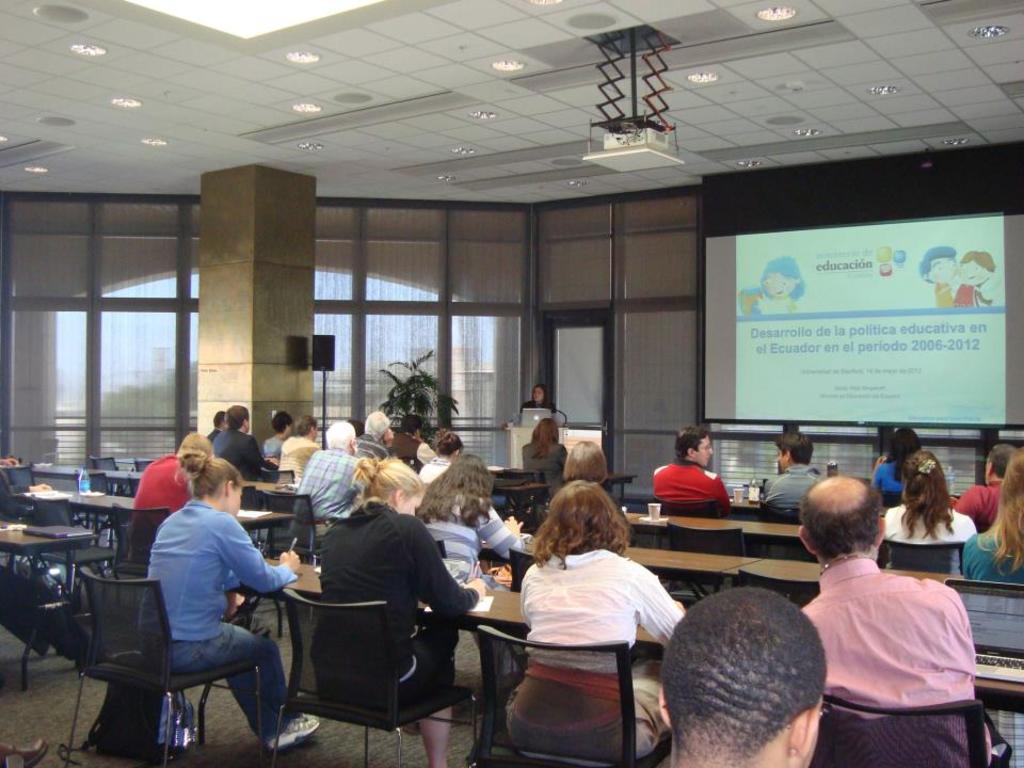In one or two sentences, can you explain what this image depicts? This picture describes about group of people few are seated on the chair and one person is standing in front of them, in front of seated people we can see books, cups, bottles on the table also we can see a projector screen in front of them. On top of them we can find projector and couple of lights. 